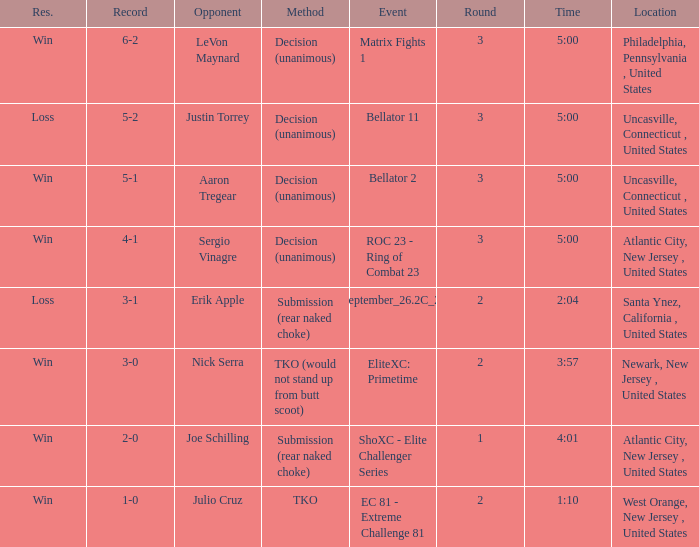Who was the opponent when there was a TKO method? Julio Cruz. 